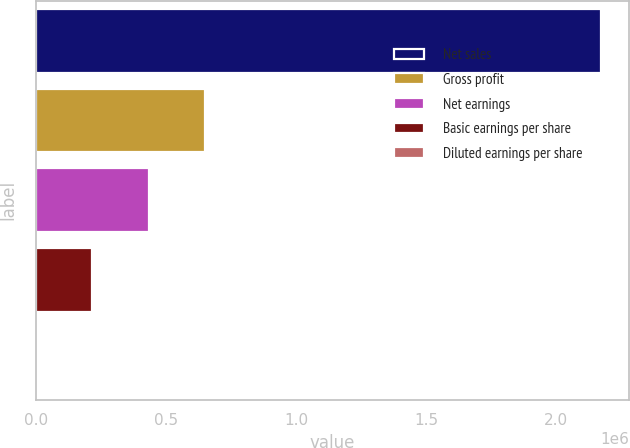<chart> <loc_0><loc_0><loc_500><loc_500><bar_chart><fcel>Net sales<fcel>Gross profit<fcel>Net earnings<fcel>Basic earnings per share<fcel>Diluted earnings per share<nl><fcel>2.17205e+06<fcel>651615<fcel>434411<fcel>217207<fcel>2.3<nl></chart> 